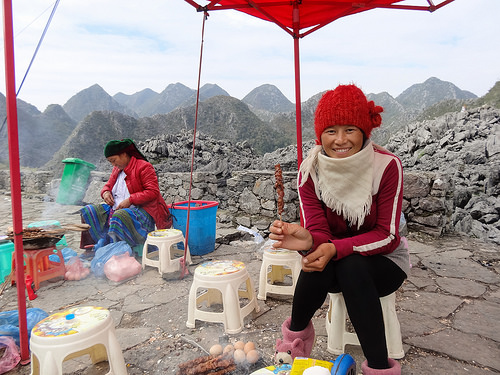<image>
Is there a woman next to the mountain? Yes. The woman is positioned adjacent to the mountain, located nearby in the same general area. 